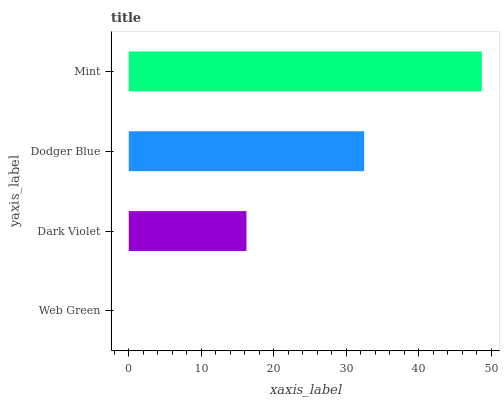Is Web Green the minimum?
Answer yes or no. Yes. Is Mint the maximum?
Answer yes or no. Yes. Is Dark Violet the minimum?
Answer yes or no. No. Is Dark Violet the maximum?
Answer yes or no. No. Is Dark Violet greater than Web Green?
Answer yes or no. Yes. Is Web Green less than Dark Violet?
Answer yes or no. Yes. Is Web Green greater than Dark Violet?
Answer yes or no. No. Is Dark Violet less than Web Green?
Answer yes or no. No. Is Dodger Blue the high median?
Answer yes or no. Yes. Is Dark Violet the low median?
Answer yes or no. Yes. Is Dark Violet the high median?
Answer yes or no. No. Is Dodger Blue the low median?
Answer yes or no. No. 